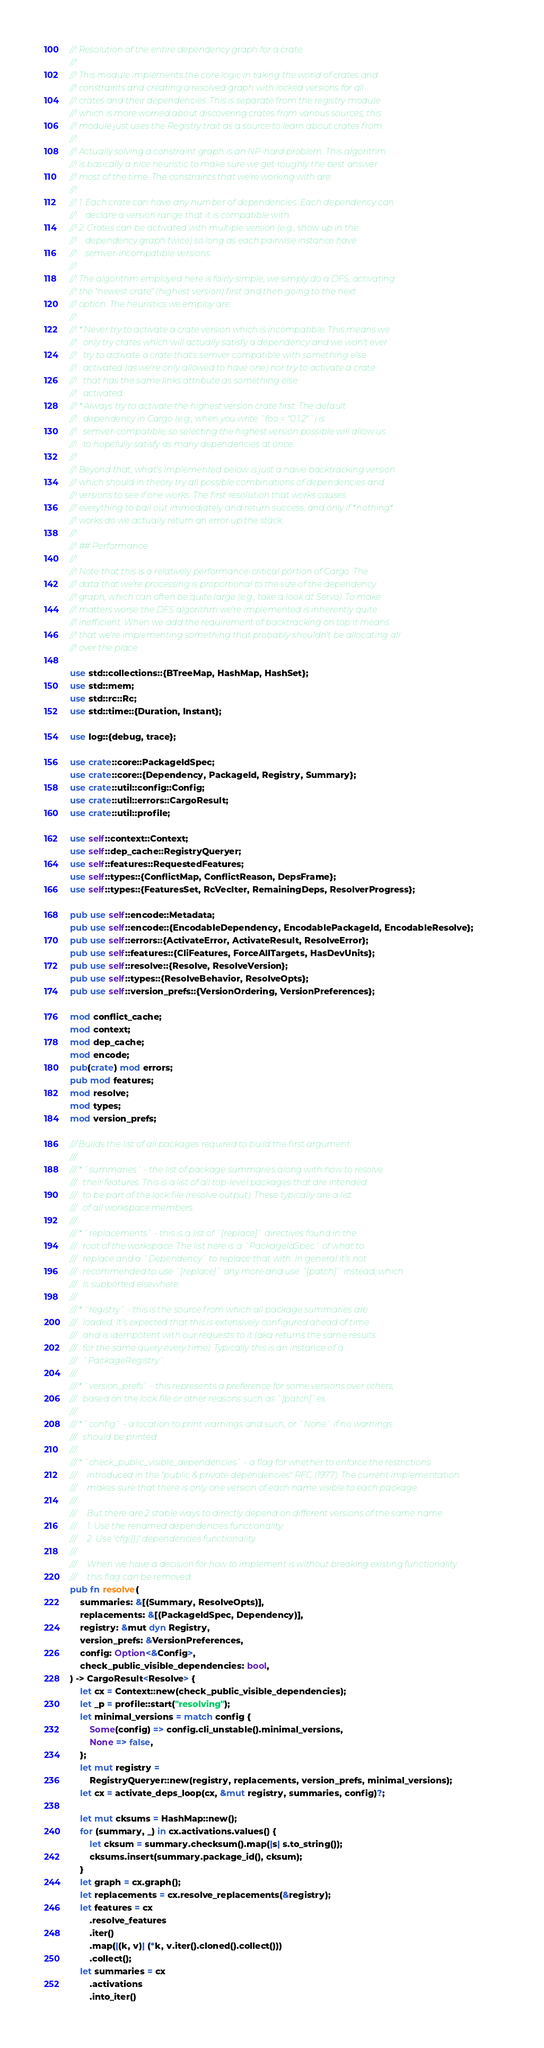Convert code to text. <code><loc_0><loc_0><loc_500><loc_500><_Rust_>//! Resolution of the entire dependency graph for a crate.
//!
//! This module implements the core logic in taking the world of crates and
//! constraints and creating a resolved graph with locked versions for all
//! crates and their dependencies. This is separate from the registry module
//! which is more worried about discovering crates from various sources, this
//! module just uses the Registry trait as a source to learn about crates from.
//!
//! Actually solving a constraint graph is an NP-hard problem. This algorithm
//! is basically a nice heuristic to make sure we get roughly the best answer
//! most of the time. The constraints that we're working with are:
//!
//! 1. Each crate can have any number of dependencies. Each dependency can
//!    declare a version range that it is compatible with.
//! 2. Crates can be activated with multiple version (e.g., show up in the
//!    dependency graph twice) so long as each pairwise instance have
//!    semver-incompatible versions.
//!
//! The algorithm employed here is fairly simple, we simply do a DFS, activating
//! the "newest crate" (highest version) first and then going to the next
//! option. The heuristics we employ are:
//!
//! * Never try to activate a crate version which is incompatible. This means we
//!   only try crates which will actually satisfy a dependency and we won't ever
//!   try to activate a crate that's semver compatible with something else
//!   activated (as we're only allowed to have one) nor try to activate a crate
//!   that has the same links attribute as something else
//!   activated.
//! * Always try to activate the highest version crate first. The default
//!   dependency in Cargo (e.g., when you write `foo = "0.1.2"`) is
//!   semver-compatible, so selecting the highest version possible will allow us
//!   to hopefully satisfy as many dependencies at once.
//!
//! Beyond that, what's implemented below is just a naive backtracking version
//! which should in theory try all possible combinations of dependencies and
//! versions to see if one works. The first resolution that works causes
//! everything to bail out immediately and return success, and only if *nothing*
//! works do we actually return an error up the stack.
//!
//! ## Performance
//!
//! Note that this is a relatively performance-critical portion of Cargo. The
//! data that we're processing is proportional to the size of the dependency
//! graph, which can often be quite large (e.g., take a look at Servo). To make
//! matters worse the DFS algorithm we're implemented is inherently quite
//! inefficient. When we add the requirement of backtracking on top it means
//! that we're implementing something that probably shouldn't be allocating all
//! over the place.

use std::collections::{BTreeMap, HashMap, HashSet};
use std::mem;
use std::rc::Rc;
use std::time::{Duration, Instant};

use log::{debug, trace};

use crate::core::PackageIdSpec;
use crate::core::{Dependency, PackageId, Registry, Summary};
use crate::util::config::Config;
use crate::util::errors::CargoResult;
use crate::util::profile;

use self::context::Context;
use self::dep_cache::RegistryQueryer;
use self::features::RequestedFeatures;
use self::types::{ConflictMap, ConflictReason, DepsFrame};
use self::types::{FeaturesSet, RcVecIter, RemainingDeps, ResolverProgress};

pub use self::encode::Metadata;
pub use self::encode::{EncodableDependency, EncodablePackageId, EncodableResolve};
pub use self::errors::{ActivateError, ActivateResult, ResolveError};
pub use self::features::{CliFeatures, ForceAllTargets, HasDevUnits};
pub use self::resolve::{Resolve, ResolveVersion};
pub use self::types::{ResolveBehavior, ResolveOpts};
pub use self::version_prefs::{VersionOrdering, VersionPreferences};

mod conflict_cache;
mod context;
mod dep_cache;
mod encode;
pub(crate) mod errors;
pub mod features;
mod resolve;
mod types;
mod version_prefs;

/// Builds the list of all packages required to build the first argument.
///
/// * `summaries` - the list of package summaries along with how to resolve
///   their features. This is a list of all top-level packages that are intended
///   to be part of the lock file (resolve output). These typically are a list
///   of all workspace members.
///
/// * `replacements` - this is a list of `[replace]` directives found in the
///   root of the workspace. The list here is a `PackageIdSpec` of what to
///   replace and a `Dependency` to replace that with. In general it's not
///   recommended to use `[replace]` any more and use `[patch]` instead, which
///   is supported elsewhere.
///
/// * `registry` - this is the source from which all package summaries are
///   loaded. It's expected that this is extensively configured ahead of time
///   and is idempotent with our requests to it (aka returns the same results
///   for the same query every time). Typically this is an instance of a
///   `PackageRegistry`.
///
/// * `version_prefs` - this represents a preference for some versions over others,
///   based on the lock file or other reasons such as `[patch]`es.
///
/// * `config` - a location to print warnings and such, or `None` if no warnings
///   should be printed
///
/// * `check_public_visible_dependencies` - a flag for whether to enforce the restrictions
///     introduced in the "public & private dependencies" RFC (1977). The current implementation
///     makes sure that there is only one version of each name visible to each package.
///
///     But there are 2 stable ways to directly depend on different versions of the same name.
///     1. Use the renamed dependencies functionality
///     2. Use 'cfg({})' dependencies functionality
///
///     When we have a decision for how to implement is without breaking existing functionality
///     this flag can be removed.
pub fn resolve(
    summaries: &[(Summary, ResolveOpts)],
    replacements: &[(PackageIdSpec, Dependency)],
    registry: &mut dyn Registry,
    version_prefs: &VersionPreferences,
    config: Option<&Config>,
    check_public_visible_dependencies: bool,
) -> CargoResult<Resolve> {
    let cx = Context::new(check_public_visible_dependencies);
    let _p = profile::start("resolving");
    let minimal_versions = match config {
        Some(config) => config.cli_unstable().minimal_versions,
        None => false,
    };
    let mut registry =
        RegistryQueryer::new(registry, replacements, version_prefs, minimal_versions);
    let cx = activate_deps_loop(cx, &mut registry, summaries, config)?;

    let mut cksums = HashMap::new();
    for (summary, _) in cx.activations.values() {
        let cksum = summary.checksum().map(|s| s.to_string());
        cksums.insert(summary.package_id(), cksum);
    }
    let graph = cx.graph();
    let replacements = cx.resolve_replacements(&registry);
    let features = cx
        .resolve_features
        .iter()
        .map(|(k, v)| (*k, v.iter().cloned().collect()))
        .collect();
    let summaries = cx
        .activations
        .into_iter()</code> 